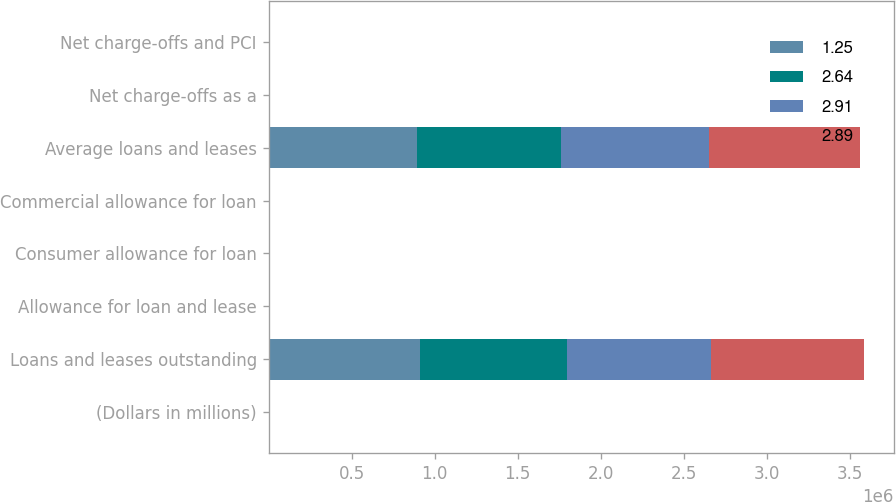Convert chart. <chart><loc_0><loc_0><loc_500><loc_500><stacked_bar_chart><ecel><fcel>(Dollars in millions)<fcel>Loans and leases outstanding<fcel>Allowance for loan and lease<fcel>Consumer allowance for loan<fcel>Commercial allowance for loan<fcel>Average loans and leases<fcel>Net charge-offs as a<fcel>Net charge-offs and PCI<nl><fcel>1.25<fcel>2016<fcel>908812<fcel>1.26<fcel>1.36<fcel>1.16<fcel>892255<fcel>0.43<fcel>0.47<nl><fcel>2.64<fcel>2015<fcel>890045<fcel>1.37<fcel>1.63<fcel>1.11<fcel>869065<fcel>0.5<fcel>0.59<nl><fcel>2.91<fcel>2014<fcel>867422<fcel>1.66<fcel>2.05<fcel>1.16<fcel>888804<fcel>0.49<fcel>0.58<nl><fcel>2.89<fcel>2013<fcel>918191<fcel>1.9<fcel>2.53<fcel>1.03<fcel>909127<fcel>0.87<fcel>1.13<nl></chart> 